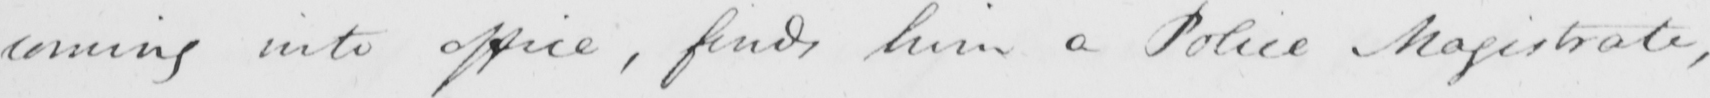Please provide the text content of this handwritten line. coming into office , finds him a Police Magistrate , 